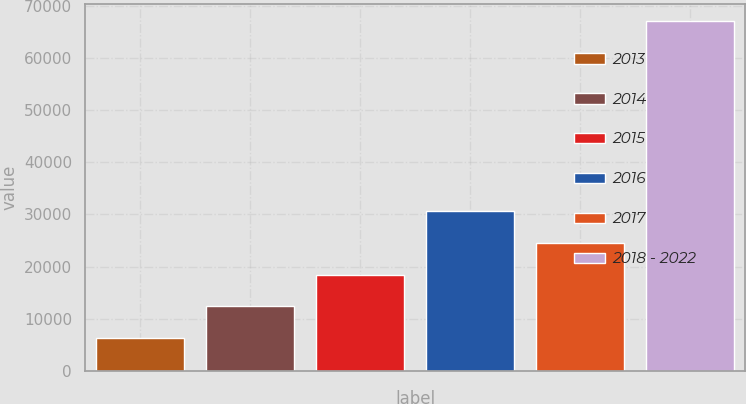Convert chart to OTSL. <chart><loc_0><loc_0><loc_500><loc_500><bar_chart><fcel>2013<fcel>2014<fcel>2015<fcel>2016<fcel>2017<fcel>2018 - 2022<nl><fcel>6307<fcel>12381.4<fcel>18455.8<fcel>30604.6<fcel>24530.2<fcel>67051<nl></chart> 